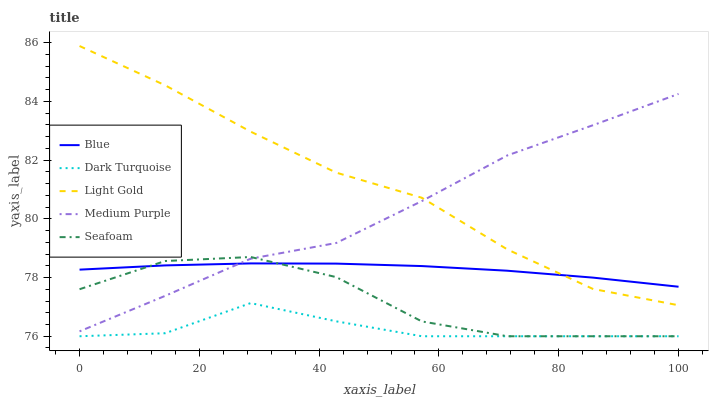Does Dark Turquoise have the minimum area under the curve?
Answer yes or no. Yes. Does Light Gold have the maximum area under the curve?
Answer yes or no. Yes. Does Medium Purple have the minimum area under the curve?
Answer yes or no. No. Does Medium Purple have the maximum area under the curve?
Answer yes or no. No. Is Blue the smoothest?
Answer yes or no. Yes. Is Seafoam the roughest?
Answer yes or no. Yes. Is Dark Turquoise the smoothest?
Answer yes or no. No. Is Dark Turquoise the roughest?
Answer yes or no. No. Does Dark Turquoise have the lowest value?
Answer yes or no. Yes. Does Medium Purple have the lowest value?
Answer yes or no. No. Does Light Gold have the highest value?
Answer yes or no. Yes. Does Medium Purple have the highest value?
Answer yes or no. No. Is Dark Turquoise less than Light Gold?
Answer yes or no. Yes. Is Light Gold greater than Seafoam?
Answer yes or no. Yes. Does Blue intersect Medium Purple?
Answer yes or no. Yes. Is Blue less than Medium Purple?
Answer yes or no. No. Is Blue greater than Medium Purple?
Answer yes or no. No. Does Dark Turquoise intersect Light Gold?
Answer yes or no. No. 